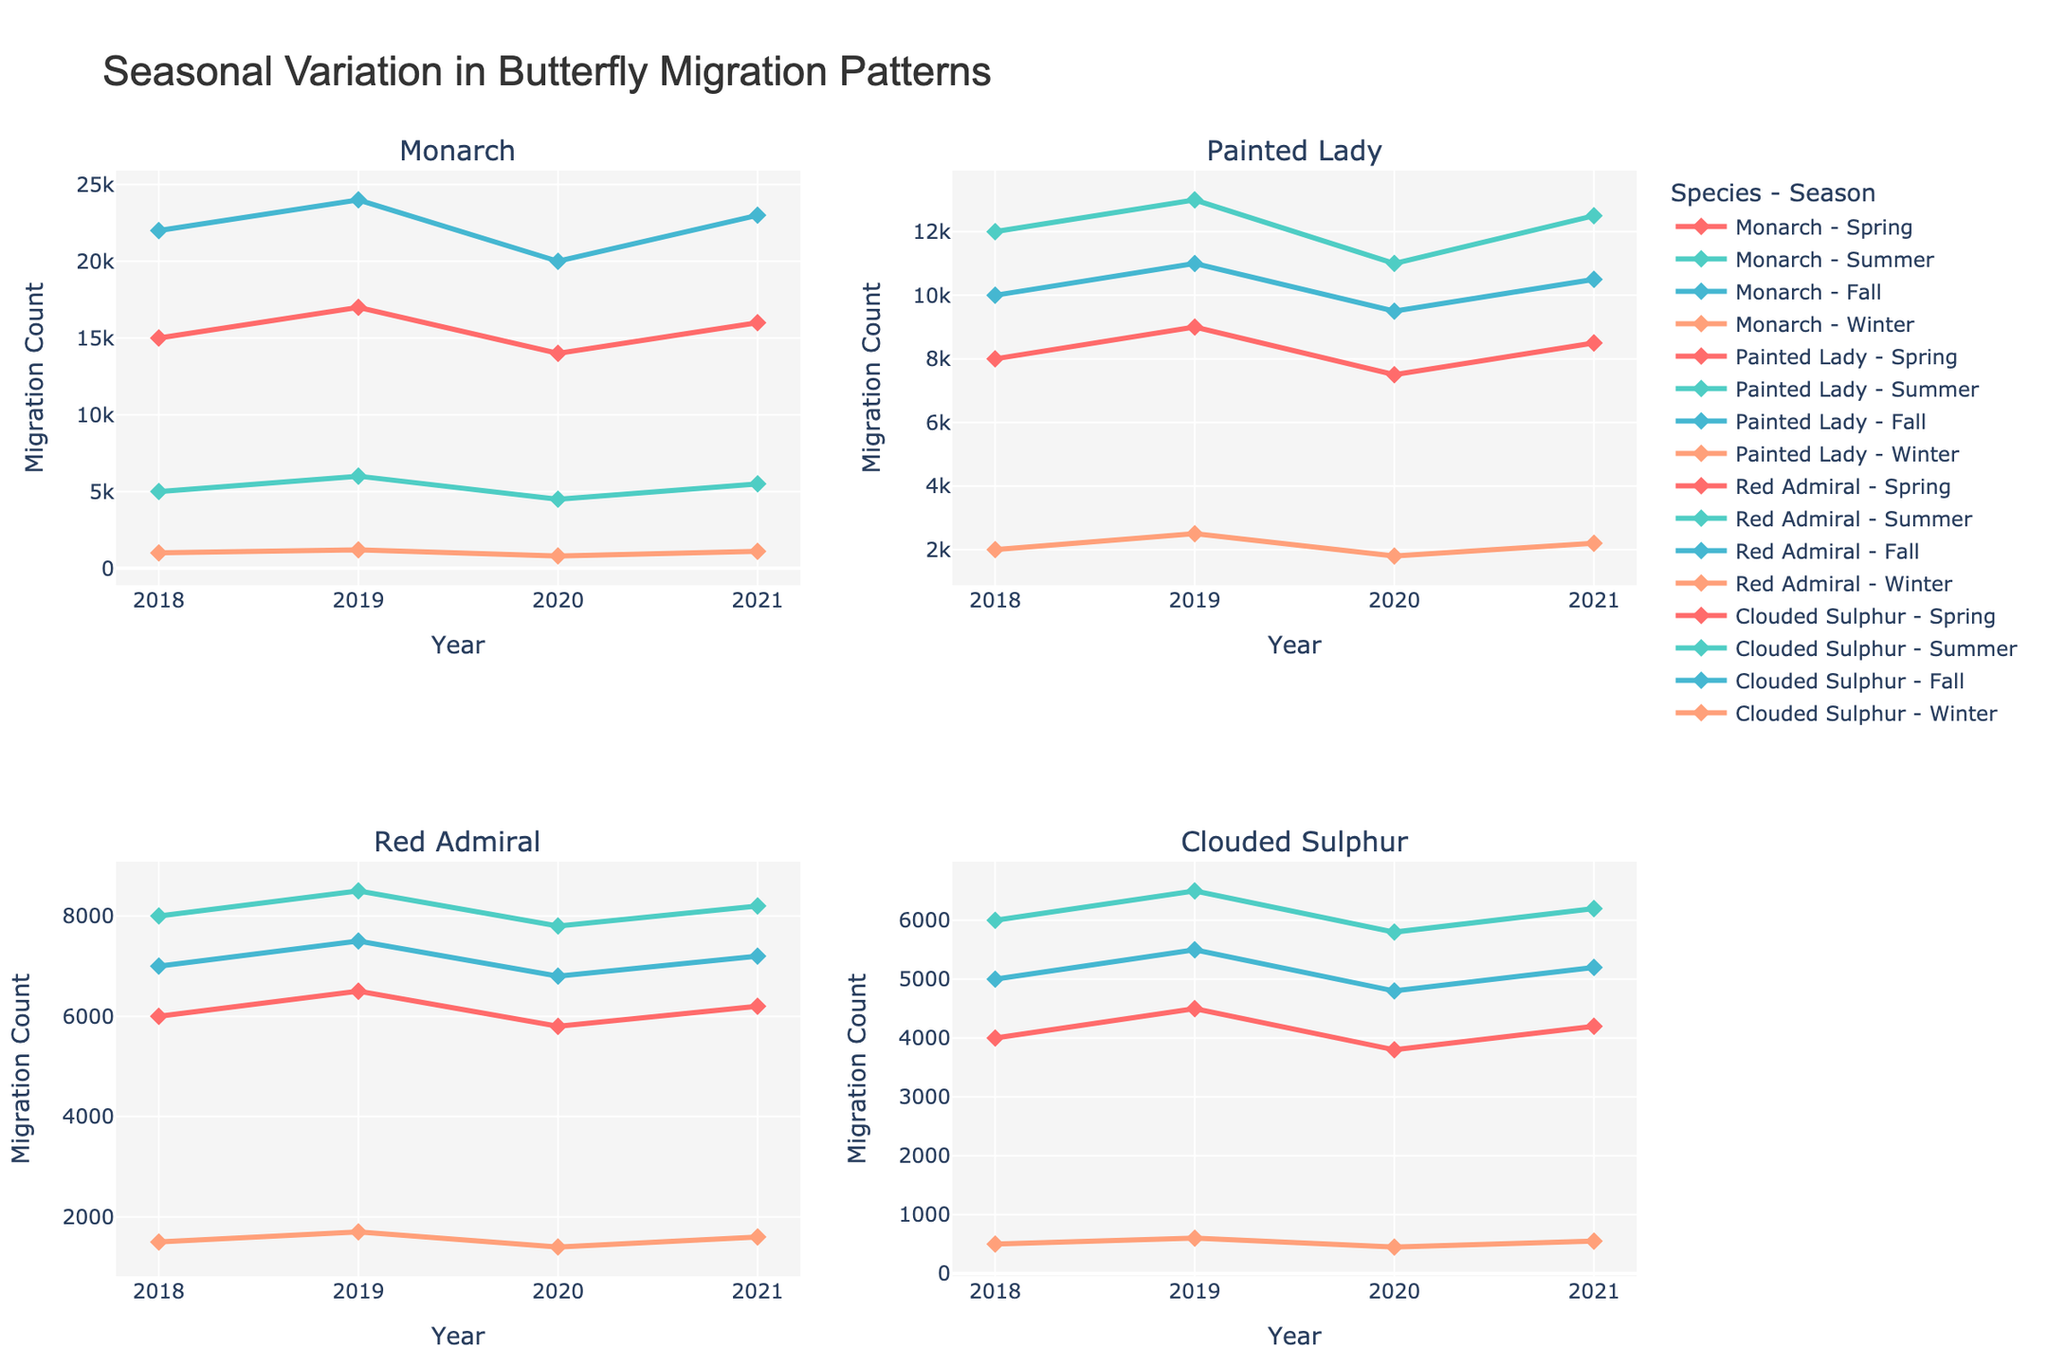Which species saw the highest migration count in Fall 2019? Look at the Fall 2019 migration counts for each species: Monarch (24000), Painted Lady (11000), Red Admiral (7500), Clouded Sulphur (5500). The Monarch has the highest count of 24000.
Answer: Monarch How did the Monarch migration count in Summer change from 2018 to 2020? In Summer 2018, the count was 5000. In Summer 2020, the count was 4500. The change is 4500 - 5000 = -500, indicating a decrease of 500.
Answer: Decreased by 500 Which season generally shows the highest migration count across all species? Summarize the count data for each season across all species and compare: Spring, Summer, Fall, Winter. Fall generally has higher counts compared to the other seasons.
Answer: Fall Which species had the greatest migration increase in Spring from 2018 to 2021? Compute the increase from 2018 to 2021 for each species in Spring: Monarch (16000 - 15000 = 1000), Painted Lady (8500 - 8000 = 500), Red Admiral (6200 - 6000 = 200), Clouded Sulphur (4200 - 4000 = 200). Monarch had the greatest increase of 1000.
Answer: Monarch What was the migration pattern of the Painted Lady in 2020 across the seasons? Look at the Painted Lady's counts in 2020 for each season: Spring (7500), Summer (11000), Fall (9500), Winter (1800). The pattern shows increasing from Spring to Summer, slight decrease in Fall, and significant drop in Winter.
Answer: Increase → Decrease → Drop Compare the Spring migration counts of Red Admiral and Clouded Sulphur in 2019. For 2019, Red Admiral's Spring count is 6500 and Clouded Sulphur's is 4500. Comparing these, Red Admiral's count is higher.
Answer: Red Admiral had higher count Which year had the smallest migration count for Monarch during Winter? Analyze Winter data for Monarch over the years: 2018 (1000), 2019 (1200), 2020 (800), 2021 (1100). The smallest count is in 2020 with 800.
Answer: 2020 What's the average migration count for the Painted Lady in Summer from 2018 to 2021? Sum up the counts in Summer for Painted Lady from 2018 to 2021 (12000 + 13000 + 11000 + 12500) = 48500. Divide by the number of years: 48500 / 4 = 12125.
Answer: 12125 What's the trend in the Clouded Sulphur migration during Winter from 2018 to 2021? Review the counts for Winter: 2018 (500), 2019 (600), 2020 (450), 2021 (550). The trend shows a slight increase from 2018 to 2019, a drop in 2020, and a rise again in 2021.
Answer: Fluctuating with a slight rise Which season had the least variation in migration count for Red Admiral over the years? Examine the variations for Red Admiral in each season over the years: Spring (6000 to 6500), Summer (8000 to 8500), Fall (7000 to 7500), Winter (1500 to 1700). Winter has the least variation (1500 to 1700 = 200).
Answer: Winter 